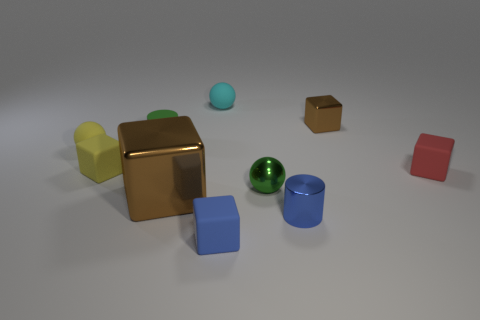What is the shape of the blue rubber thing that is the same size as the yellow block?
Keep it short and to the point. Cube. Is there a object of the same color as the matte cylinder?
Your answer should be very brief. Yes. Does the large shiny thing have the same color as the ball that is behind the tiny yellow sphere?
Make the answer very short. No. What color is the thing that is behind the brown metal thing that is right of the green metallic thing?
Make the answer very short. Cyan. Is there a small rubber ball on the right side of the tiny rubber sphere behind the brown object that is behind the red thing?
Give a very brief answer. No. What color is the small cylinder that is made of the same material as the tiny blue cube?
Your response must be concise. Green. How many large brown blocks are the same material as the small yellow cube?
Provide a succinct answer. 0. Is the green ball made of the same material as the brown thing to the left of the metal cylinder?
Provide a succinct answer. Yes. How many things are either red things in front of the cyan rubber sphere or brown objects?
Your answer should be very brief. 3. How big is the brown block in front of the tiny matte cube to the right of the brown object right of the big brown object?
Your answer should be very brief. Large. 